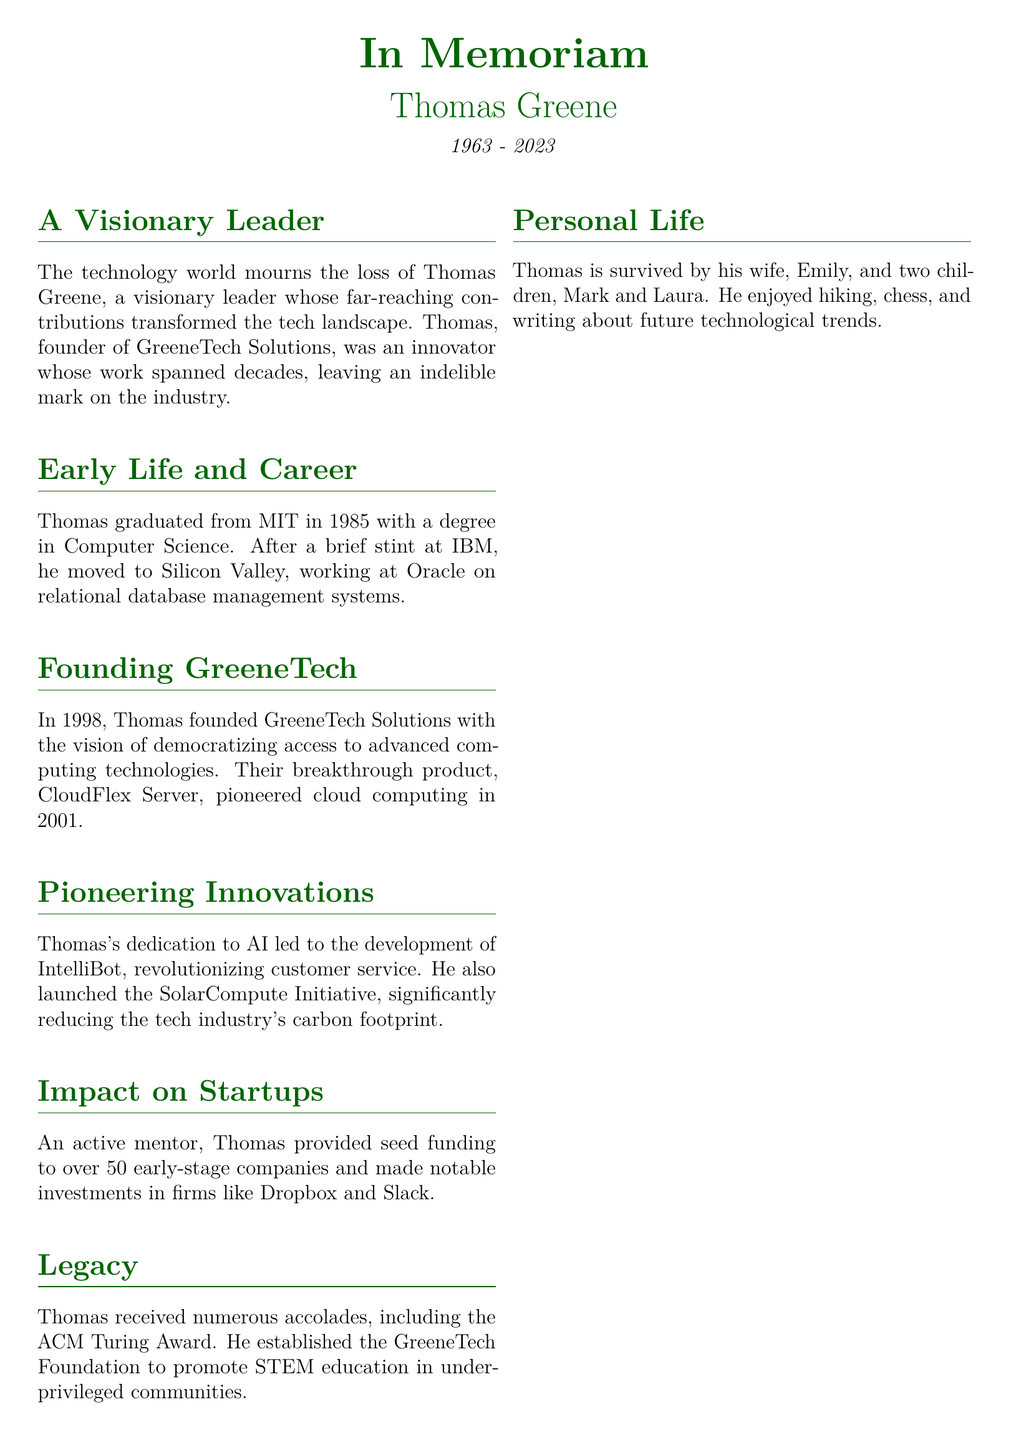What year was Thomas Greene born? The document states that Thomas Greene was born in 1963.
Answer: 1963 What was the name of Thomas Greene's company? The obituary mentions that Thomas founded GreeneTech Solutions.
Answer: GreeneTech Solutions What significant product did GreeneTech Solutions launch in 2001? The document specifies that the breakthrough product launched was CloudFlex Server.
Answer: CloudFlex Server How many early-stage companies did Thomas provide seed funding to? The document states that Thomas provided seed funding to over 50 companies.
Answer: over 50 Which award did Thomas Greene receive? It is mentioned in the document that Thomas received the ACM Turing Award.
Answer: ACM Turing Award What initiative did Thomas launch to reduce the carbon footprint of the tech industry? The document refers to the initiative he launched as the SolarCompute Initiative.
Answer: SolarCompute Initiative What was the focus of the GreeneTech Foundation? The obituary notes that the foundation promotes STEM education in underprivileged communities.
Answer: STEM education What degree did Thomas graduate with? The document states that Thomas graduated with a degree in Computer Science.
Answer: Computer Science In which year did Thomas found GreeneTech Solutions? The document specifies that GreeneTech Solutions was founded in 1998.
Answer: 1998 